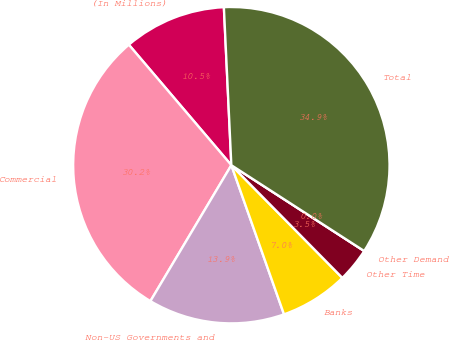Convert chart. <chart><loc_0><loc_0><loc_500><loc_500><pie_chart><fcel>(In Millions)<fcel>Commercial<fcel>Non-US Governments and<fcel>Banks<fcel>Other Time<fcel>Other Demand<fcel>Total<nl><fcel>10.47%<fcel>30.23%<fcel>13.95%<fcel>6.98%<fcel>3.49%<fcel>0.0%<fcel>34.88%<nl></chart> 